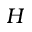Convert formula to latex. <formula><loc_0><loc_0><loc_500><loc_500>H</formula> 